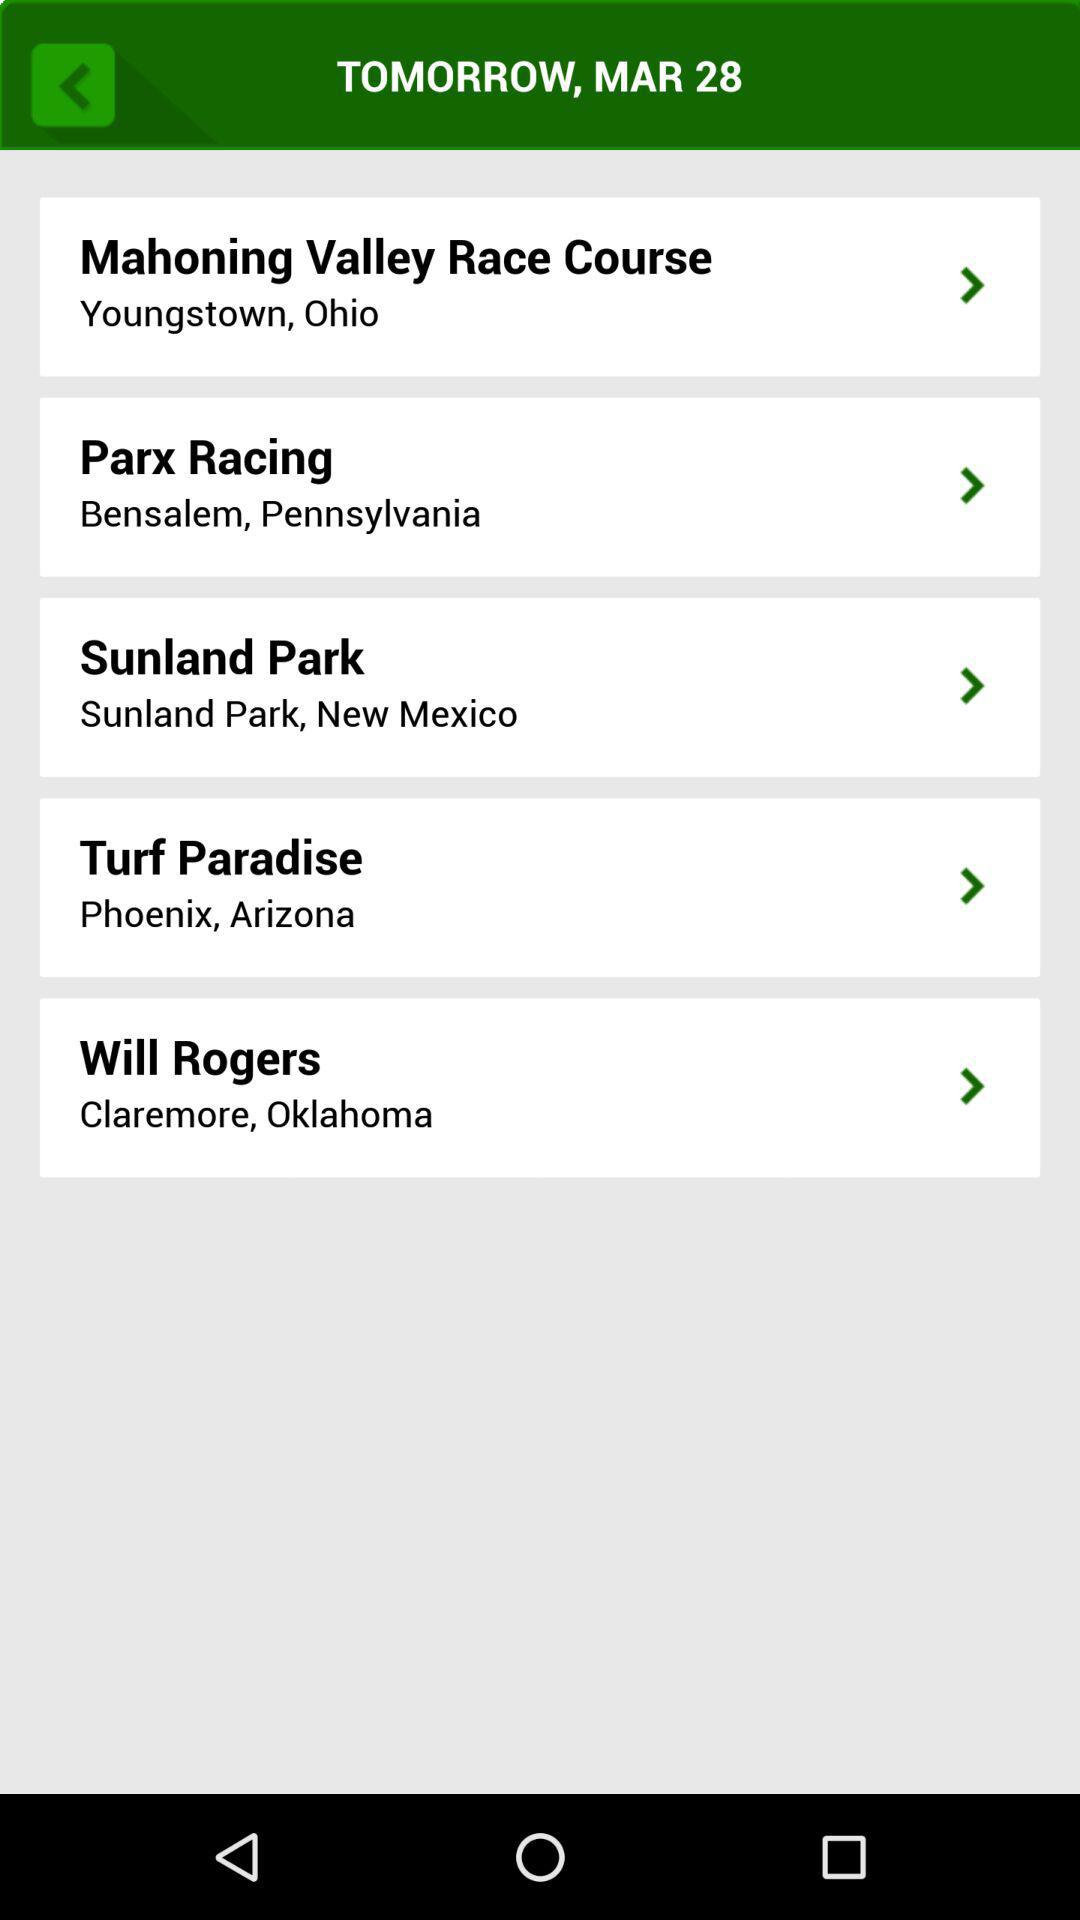What is the shown date? The shown date is March 28. 